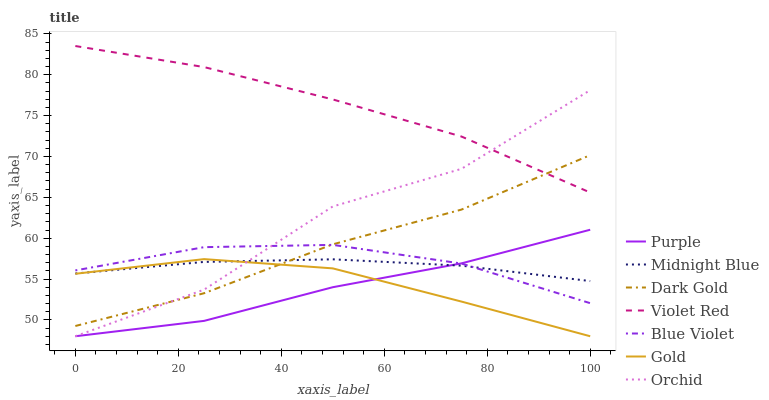Does Purple have the minimum area under the curve?
Answer yes or no. Yes. Does Violet Red have the maximum area under the curve?
Answer yes or no. Yes. Does Midnight Blue have the minimum area under the curve?
Answer yes or no. No. Does Midnight Blue have the maximum area under the curve?
Answer yes or no. No. Is Midnight Blue the smoothest?
Answer yes or no. Yes. Is Orchid the roughest?
Answer yes or no. Yes. Is Gold the smoothest?
Answer yes or no. No. Is Gold the roughest?
Answer yes or no. No. Does Gold have the lowest value?
Answer yes or no. Yes. Does Midnight Blue have the lowest value?
Answer yes or no. No. Does Violet Red have the highest value?
Answer yes or no. Yes. Does Gold have the highest value?
Answer yes or no. No. Is Purple less than Violet Red?
Answer yes or no. Yes. Is Violet Red greater than Blue Violet?
Answer yes or no. Yes. Does Gold intersect Orchid?
Answer yes or no. Yes. Is Gold less than Orchid?
Answer yes or no. No. Is Gold greater than Orchid?
Answer yes or no. No. Does Purple intersect Violet Red?
Answer yes or no. No. 